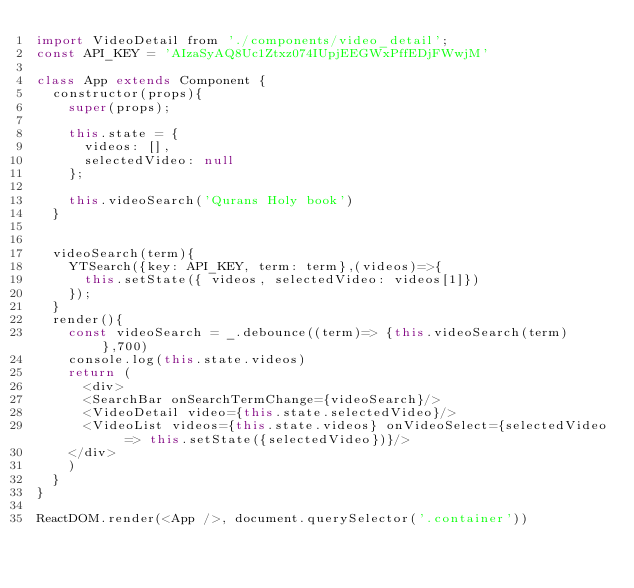Convert code to text. <code><loc_0><loc_0><loc_500><loc_500><_JavaScript_>import VideoDetail from './components/video_detail';
const API_KEY = 'AIzaSyAQ8Uc1Ztxz074IUpjEEGWxPffEDjFWwjM'

class App extends Component {
  constructor(props){
    super(props);

    this.state = {
      videos: [],
      selectedVideo: null
    };

    this.videoSearch('Qurans Holy book')
  }


  videoSearch(term){
    YTSearch({key: API_KEY, term: term},(videos)=>{
      this.setState({ videos, selectedVideo: videos[1]})
    });
  }
  render(){
    const videoSearch = _.debounce((term)=> {this.videoSearch(term)},700)
    console.log(this.state.videos)
    return (
      <div>
      <SearchBar onSearchTermChange={videoSearch}/>
      <VideoDetail video={this.state.selectedVideo}/>
      <VideoList videos={this.state.videos} onVideoSelect={selectedVideo => this.setState({selectedVideo})}/>
    </div>
    )
  }
}

ReactDOM.render(<App />, document.querySelector('.container'))
</code> 